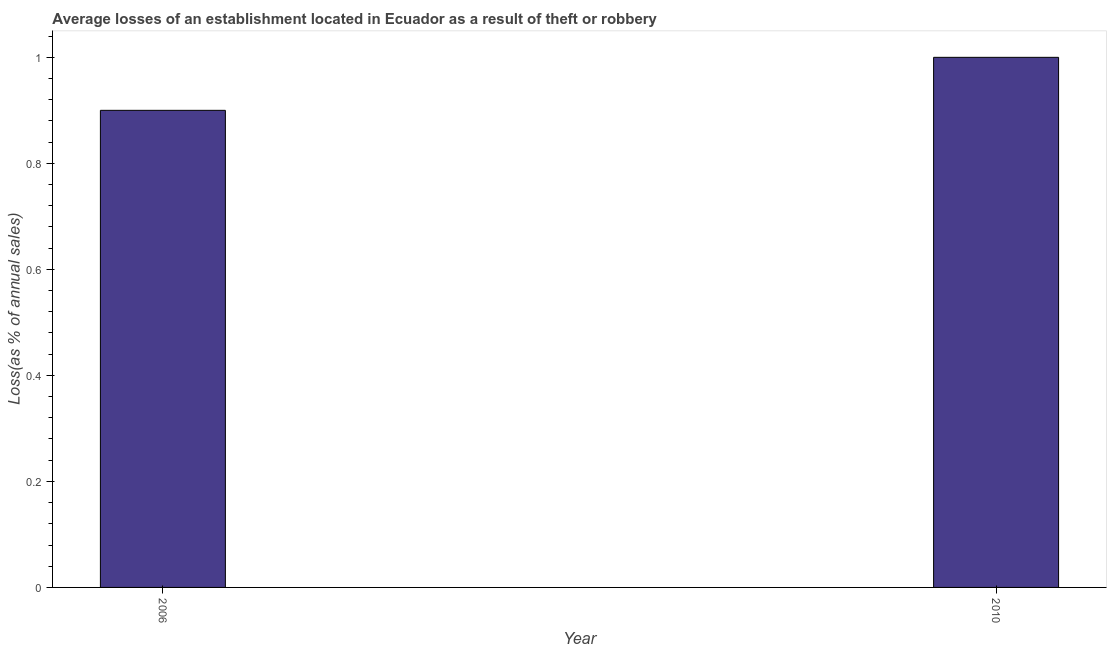What is the title of the graph?
Your response must be concise. Average losses of an establishment located in Ecuador as a result of theft or robbery. What is the label or title of the Y-axis?
Make the answer very short. Loss(as % of annual sales). Across all years, what is the minimum losses due to theft?
Provide a succinct answer. 0.9. In which year was the losses due to theft minimum?
Make the answer very short. 2006. What is the difference between the losses due to theft in 2006 and 2010?
Offer a terse response. -0.1. In how many years, is the losses due to theft greater than 0.68 %?
Your answer should be very brief. 2. Do a majority of the years between 2006 and 2010 (inclusive) have losses due to theft greater than 0.2 %?
Provide a short and direct response. Yes. In how many years, is the losses due to theft greater than the average losses due to theft taken over all years?
Ensure brevity in your answer.  1. How many bars are there?
Ensure brevity in your answer.  2. How many years are there in the graph?
Keep it short and to the point. 2. What is the difference between two consecutive major ticks on the Y-axis?
Ensure brevity in your answer.  0.2. Are the values on the major ticks of Y-axis written in scientific E-notation?
Offer a very short reply. No. What is the Loss(as % of annual sales) of 2006?
Give a very brief answer. 0.9. What is the ratio of the Loss(as % of annual sales) in 2006 to that in 2010?
Give a very brief answer. 0.9. 